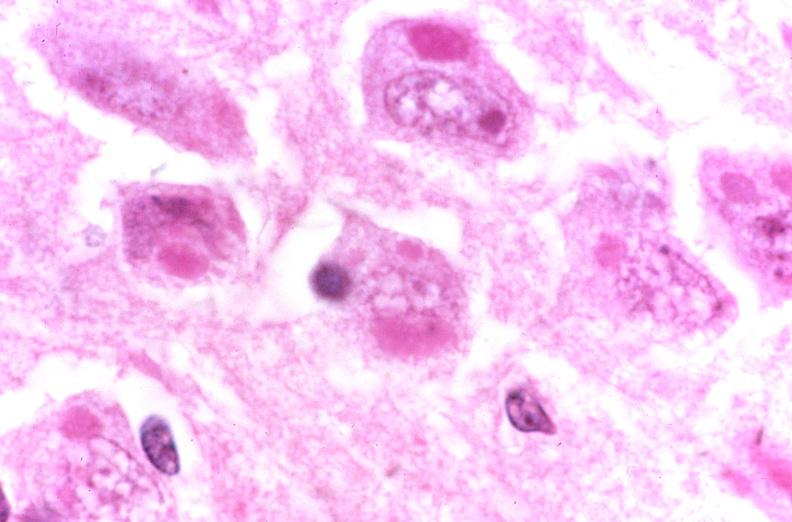what does this image show?
Answer the question using a single word or phrase. Brain 